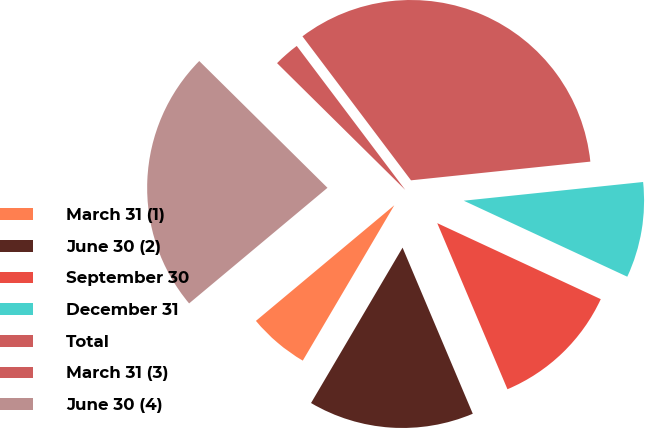<chart> <loc_0><loc_0><loc_500><loc_500><pie_chart><fcel>March 31 (1)<fcel>June 30 (2)<fcel>September 30<fcel>December 31<fcel>Total<fcel>March 31 (3)<fcel>June 30 (4)<nl><fcel>5.45%<fcel>14.84%<fcel>11.71%<fcel>8.58%<fcel>33.63%<fcel>2.31%<fcel>23.49%<nl></chart> 